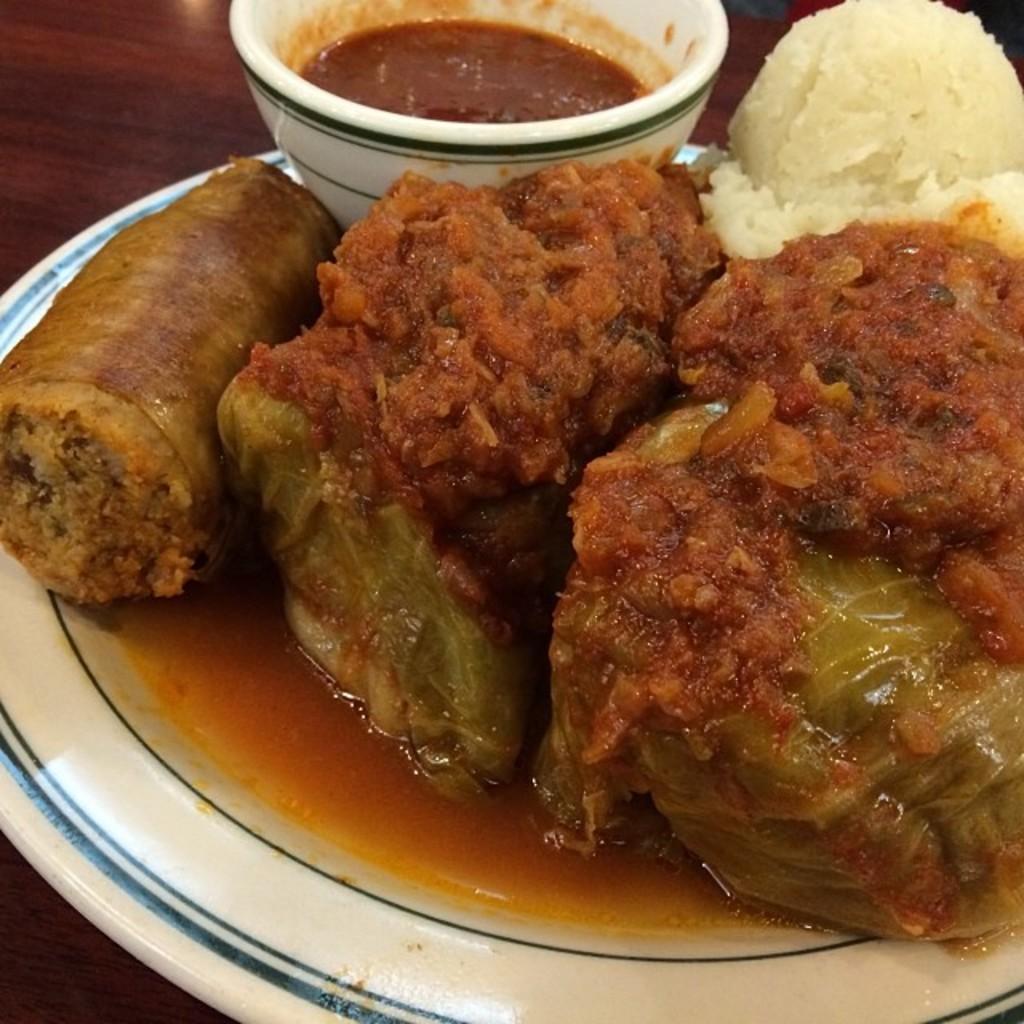In one or two sentences, can you explain what this image depicts? In this picture we can see plate, food and bowl on the wooden platform. 